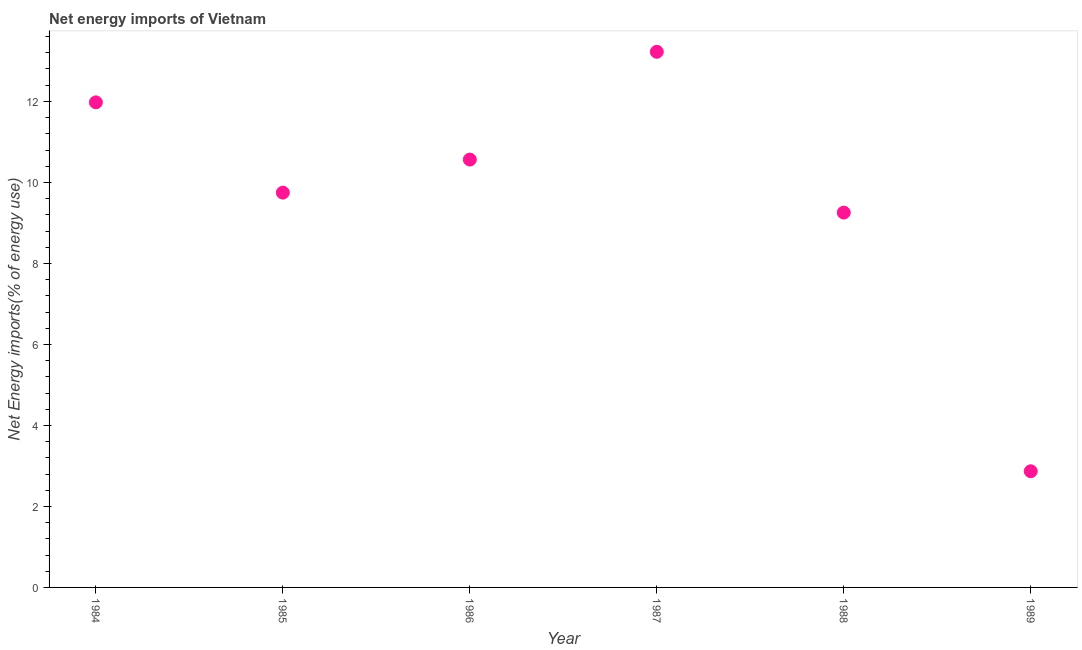What is the energy imports in 1984?
Your response must be concise. 11.98. Across all years, what is the maximum energy imports?
Your answer should be very brief. 13.22. Across all years, what is the minimum energy imports?
Your answer should be very brief. 2.87. In which year was the energy imports maximum?
Make the answer very short. 1987. What is the sum of the energy imports?
Offer a terse response. 57.64. What is the difference between the energy imports in 1986 and 1988?
Give a very brief answer. 1.31. What is the average energy imports per year?
Ensure brevity in your answer.  9.61. What is the median energy imports?
Provide a short and direct response. 10.16. What is the ratio of the energy imports in 1985 to that in 1987?
Provide a succinct answer. 0.74. Is the energy imports in 1987 less than that in 1989?
Make the answer very short. No. Is the difference between the energy imports in 1985 and 1986 greater than the difference between any two years?
Provide a short and direct response. No. What is the difference between the highest and the second highest energy imports?
Ensure brevity in your answer.  1.25. Is the sum of the energy imports in 1984 and 1987 greater than the maximum energy imports across all years?
Your answer should be very brief. Yes. What is the difference between the highest and the lowest energy imports?
Your answer should be very brief. 10.36. Does the energy imports monotonically increase over the years?
Keep it short and to the point. No. How many dotlines are there?
Offer a terse response. 1. What is the difference between two consecutive major ticks on the Y-axis?
Offer a very short reply. 2. Are the values on the major ticks of Y-axis written in scientific E-notation?
Ensure brevity in your answer.  No. What is the title of the graph?
Offer a very short reply. Net energy imports of Vietnam. What is the label or title of the Y-axis?
Keep it short and to the point. Net Energy imports(% of energy use). What is the Net Energy imports(% of energy use) in 1984?
Make the answer very short. 11.98. What is the Net Energy imports(% of energy use) in 1985?
Provide a short and direct response. 9.75. What is the Net Energy imports(% of energy use) in 1986?
Your response must be concise. 10.56. What is the Net Energy imports(% of energy use) in 1987?
Your answer should be compact. 13.22. What is the Net Energy imports(% of energy use) in 1988?
Give a very brief answer. 9.25. What is the Net Energy imports(% of energy use) in 1989?
Offer a terse response. 2.87. What is the difference between the Net Energy imports(% of energy use) in 1984 and 1985?
Keep it short and to the point. 2.23. What is the difference between the Net Energy imports(% of energy use) in 1984 and 1986?
Ensure brevity in your answer.  1.41. What is the difference between the Net Energy imports(% of energy use) in 1984 and 1987?
Give a very brief answer. -1.25. What is the difference between the Net Energy imports(% of energy use) in 1984 and 1988?
Make the answer very short. 2.72. What is the difference between the Net Energy imports(% of energy use) in 1984 and 1989?
Give a very brief answer. 9.11. What is the difference between the Net Energy imports(% of energy use) in 1985 and 1986?
Make the answer very short. -0.82. What is the difference between the Net Energy imports(% of energy use) in 1985 and 1987?
Keep it short and to the point. -3.48. What is the difference between the Net Energy imports(% of energy use) in 1985 and 1988?
Provide a succinct answer. 0.49. What is the difference between the Net Energy imports(% of energy use) in 1985 and 1989?
Provide a succinct answer. 6.88. What is the difference between the Net Energy imports(% of energy use) in 1986 and 1987?
Keep it short and to the point. -2.66. What is the difference between the Net Energy imports(% of energy use) in 1986 and 1988?
Your response must be concise. 1.31. What is the difference between the Net Energy imports(% of energy use) in 1986 and 1989?
Give a very brief answer. 7.7. What is the difference between the Net Energy imports(% of energy use) in 1987 and 1988?
Provide a succinct answer. 3.97. What is the difference between the Net Energy imports(% of energy use) in 1987 and 1989?
Ensure brevity in your answer.  10.36. What is the difference between the Net Energy imports(% of energy use) in 1988 and 1989?
Keep it short and to the point. 6.39. What is the ratio of the Net Energy imports(% of energy use) in 1984 to that in 1985?
Your answer should be very brief. 1.23. What is the ratio of the Net Energy imports(% of energy use) in 1984 to that in 1986?
Provide a succinct answer. 1.13. What is the ratio of the Net Energy imports(% of energy use) in 1984 to that in 1987?
Your answer should be compact. 0.91. What is the ratio of the Net Energy imports(% of energy use) in 1984 to that in 1988?
Offer a very short reply. 1.29. What is the ratio of the Net Energy imports(% of energy use) in 1984 to that in 1989?
Make the answer very short. 4.18. What is the ratio of the Net Energy imports(% of energy use) in 1985 to that in 1986?
Offer a terse response. 0.92. What is the ratio of the Net Energy imports(% of energy use) in 1985 to that in 1987?
Ensure brevity in your answer.  0.74. What is the ratio of the Net Energy imports(% of energy use) in 1985 to that in 1988?
Your answer should be very brief. 1.05. What is the ratio of the Net Energy imports(% of energy use) in 1985 to that in 1989?
Keep it short and to the point. 3.4. What is the ratio of the Net Energy imports(% of energy use) in 1986 to that in 1987?
Provide a succinct answer. 0.8. What is the ratio of the Net Energy imports(% of energy use) in 1986 to that in 1988?
Provide a succinct answer. 1.14. What is the ratio of the Net Energy imports(% of energy use) in 1986 to that in 1989?
Provide a short and direct response. 3.68. What is the ratio of the Net Energy imports(% of energy use) in 1987 to that in 1988?
Keep it short and to the point. 1.43. What is the ratio of the Net Energy imports(% of energy use) in 1987 to that in 1989?
Ensure brevity in your answer.  4.61. What is the ratio of the Net Energy imports(% of energy use) in 1988 to that in 1989?
Keep it short and to the point. 3.23. 